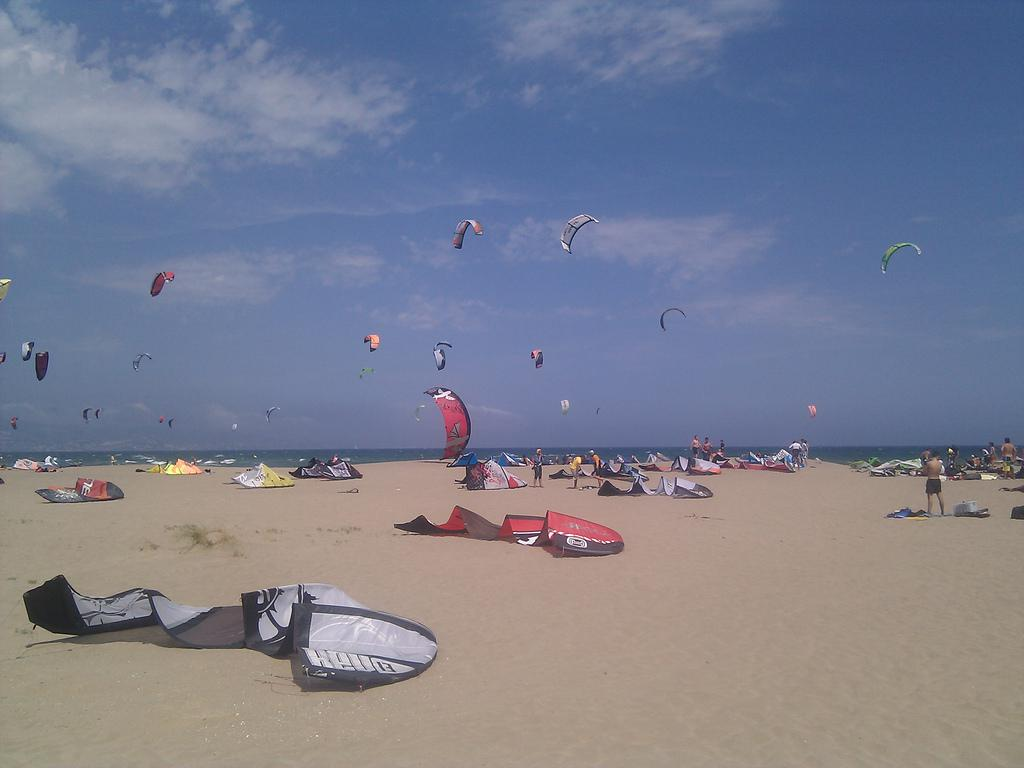Question: where do you fly a kite?
Choices:
A. The beach.
B. At the park.
C. In the backyard.
D. In an empty lot.
Answer with the letter. Answer: A Question: why is it so crowded at the beach?
Choices:
A. It's a holiday weekend.
B. There is a kite festival.
C. A lovely day.
D. It's spring break.
Answer with the letter. Answer: C Question: how is the weather?
Choices:
A. Clear skies with blue clouds.
B. Overcast.
C. Warm and humid.
D. Cold and rainy.
Answer with the letter. Answer: A Question: where have people gathered?
Choices:
A. On a field.
B. In a stadium.
C. At a tennis court.
D. On a beach.
Answer with the letter. Answer: D Question: where can you see a person in a yellow shirt?
Choices:
A. On the left.
B. Right in middle.
C. On the right.
D. In the back.
Answer with the letter. Answer: B Question: what is the person in dark shorts doing?
Choices:
A. Running.
B. Flying a kite.
C. Talking.
D. Smiling.
Answer with the letter. Answer: B Question: how is the white kite bordered in black positioned?
Choices:
A. On the ground.
B. In the foreground.
C. In the sky.
D. In someones hands.
Answer with the letter. Answer: B Question: what flies low to the ground?
Choices:
A. One plane.
B. One bee.
C. One red kite.
D. One fly.
Answer with the letter. Answer: C Question: what cannot be seen in the distance?
Choices:
A. Waves.
B. Trees.
C. Flowers.
D. House.
Answer with the letter. Answer: A Question: what has been left lying on the beach?
Choices:
A. Many kites.
B. Many balls.
C. Many scraps.
D. Many shells.
Answer with the letter. Answer: A Question: what do the kites laying on the beach not have?
Choices:
A. Tails.
B. Colors.
C. Boards.
D. Owners.
Answer with the letter. Answer: D Question: where is the yellow kite?
Choices:
A. In the distance.
B. In the sky.
C. At the end of the string.
D. At the toy store.
Answer with the letter. Answer: A Question: what did people bring to the beach to do?
Choices:
A. Something to read.
B. Sandwiches to eat later.
C. Crossword puzzles.
D. Their kites.
Answer with the letter. Answer: D Question: where are all the kites?
Choices:
A. In the back of the station wagon.
B. Some are in the air and some are on the sand.
C. On display at the toy store.
D. In people's hands.
Answer with the letter. Answer: B Question: what is lying on the beach?
Choices:
A. Many shells.
B. Many shoes.
C. Many people.
D. Many kites.
Answer with the letter. Answer: D 